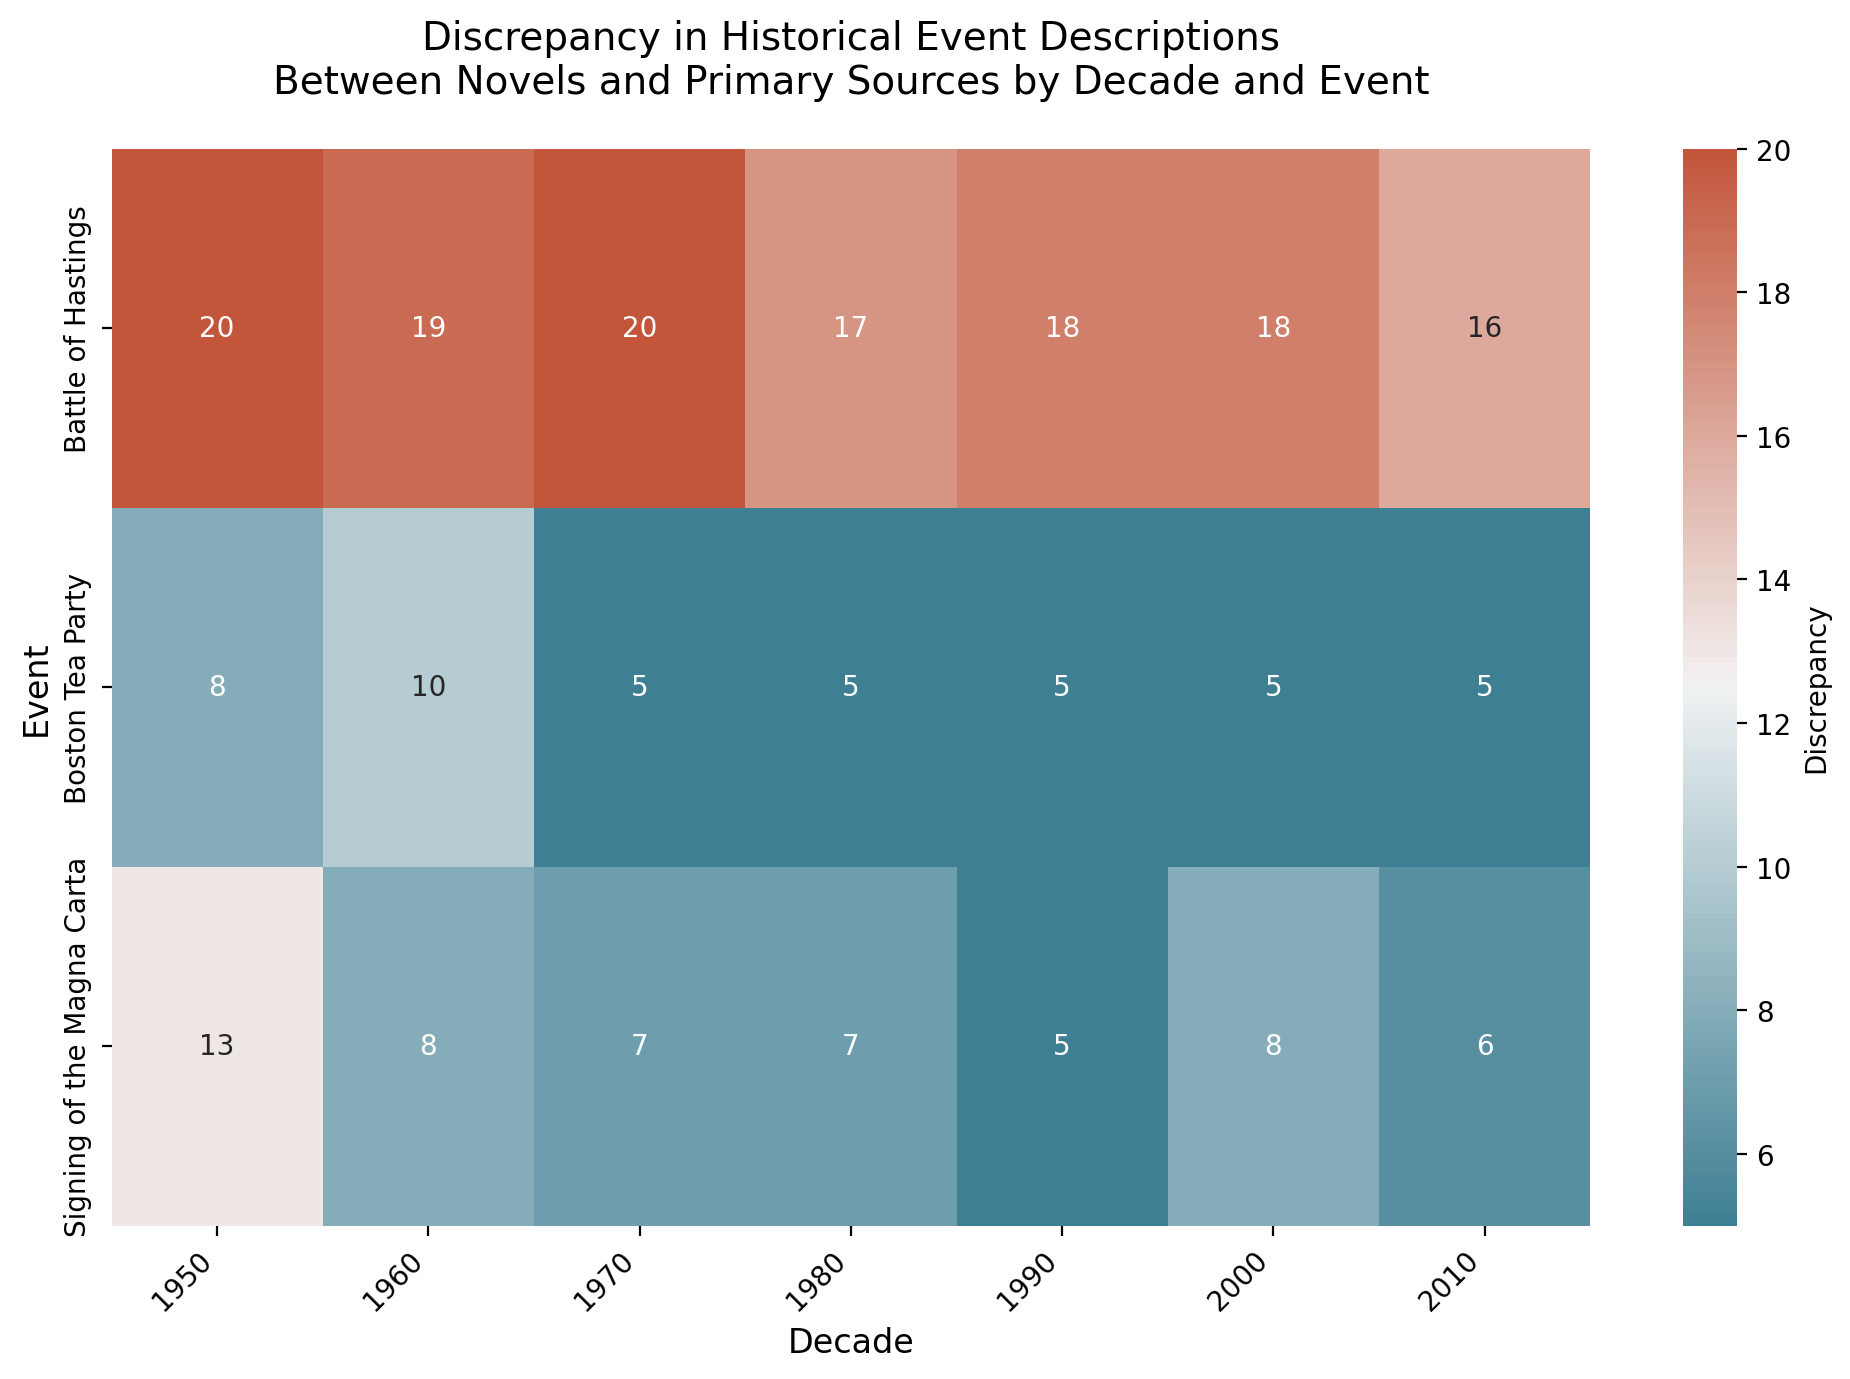What's the largest discrepancy in historical event descriptions across all decades? To find the largest discrepancy, look at the "Discrepancy" values in the heatmap and find the maximum number. The "Battle of Hastings" in the 1950s and 1970s shows the highest discrepancy of 20.
Answer: 20 Which event consistently shows the lowest discrepancy across all decades? Examine the "Discrepancy" values for each event across all decades and identify the event with the smallest numbers. The "Boston Tea Party" consistently shows the lowest discrepancies, never exceeding a value of 10.
Answer: Boston Tea Party In which decade does the "Signing of the Magna Carta" have the highest discrepancy? Look at the "Discrepancy" values for the "Signing of the Magna Carta" row across all decades. The highest value is in the 1950s with a discrepancy of 13.
Answer: 1950 How does the discrepancy of the "Battle of Hastings" in the 2010s compare to its discrepancy in the 1980s? Compare the discrepancy values of the "Battle of Hastings" in the 2010s and the 1980s. In the 2010s, the discrepancy is 16 and in the 1980s it is 17.
Answer: It decreased by 1 What is the average discrepancy for the "Boston Tea Party" across all decades? Find the discrepancy values for the "Boston Tea Party" for all decades (8, 10, 5, 5, 5, 5), sum them (38), and divide by the number of decades (6).
Answer: 6.33 Which decade shows the smallest average discrepancy across all events? Calculate the average discrepancy for each decade by summing the discrepancy values and dividing by the number of events: 1950s: 13.67, 1960s: 12.33, 1970s: 10.67, 1980s: 9.67, 1990s: 9.33, 2000s: 10.33, 2010s: 9.  The smallest average is in the 2010s.
Answer: 2010 Compare the discrepancy trends over the decades for the "Battle of Hastings" and "Signing of the Magna Carta". Identify the discrepancy values for both events across the decades and describe their trends. "Battle of Hastings" fluctuates: 20, 19, 20, 17, 18, 18, 16. "Signing of the Magna Carta" shows a decreasing trend: 13, 8, 7, 7, 5, 8, 6.
Answer: "Battle of Hastings" fluctuates; "Signing of the Magna Carta" decreases 